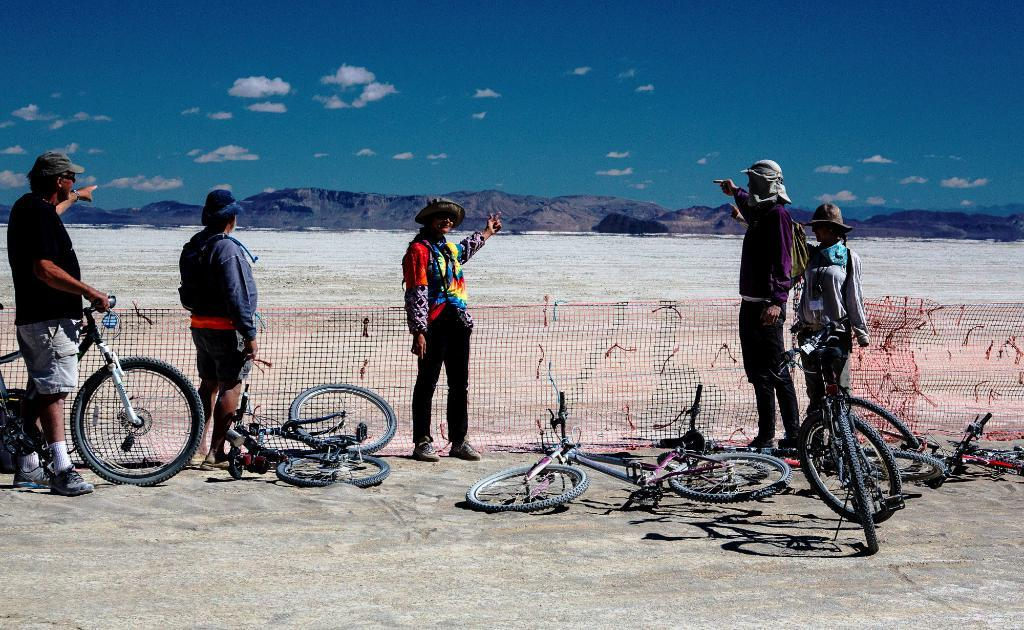How many people are in the image? There are five persons in the image. What are the people in the image doing? All the persons are standing. What objects can be seen in the image besides the people? There are bicycles, a net, and hills visible in the image. What is visible in the sky in the image? The sky is visible in the image, and clouds are present. What type of terrain is visible in the image? There is sand visible in the image. What color is the hair of the chickens in the image? There are no chickens present in the image, so there is no hair to describe. What type of observation can be made about the net in the image? The provided facts do not mention any specific details about the net, so it is not possible to make an observation about it. 